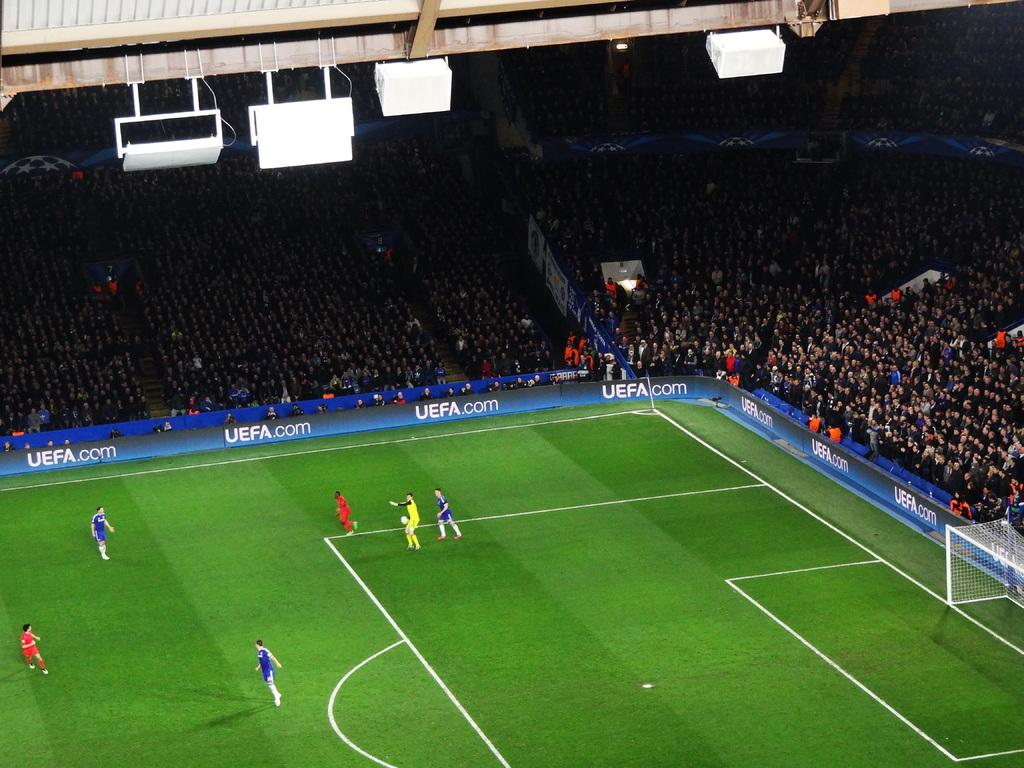<image>
Summarize the visual content of the image. A soccer field with UEFA.com banners on the side 